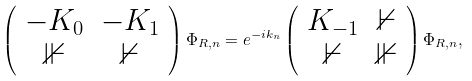Convert formula to latex. <formula><loc_0><loc_0><loc_500><loc_500>\left ( \begin{array} { c c } - K _ { 0 } & - K _ { 1 } \\ \mathbb { 1 } & \mathbb { 0 } \end{array} \right ) \Phi _ { R , n } = e ^ { - i k _ { n } } \left ( \begin{array} { c c } K _ { - 1 } & \mathbb { 0 } \\ \mathbb { 0 } & \mathbb { 1 } \end{array} \right ) \Phi _ { R , n } ,</formula> 